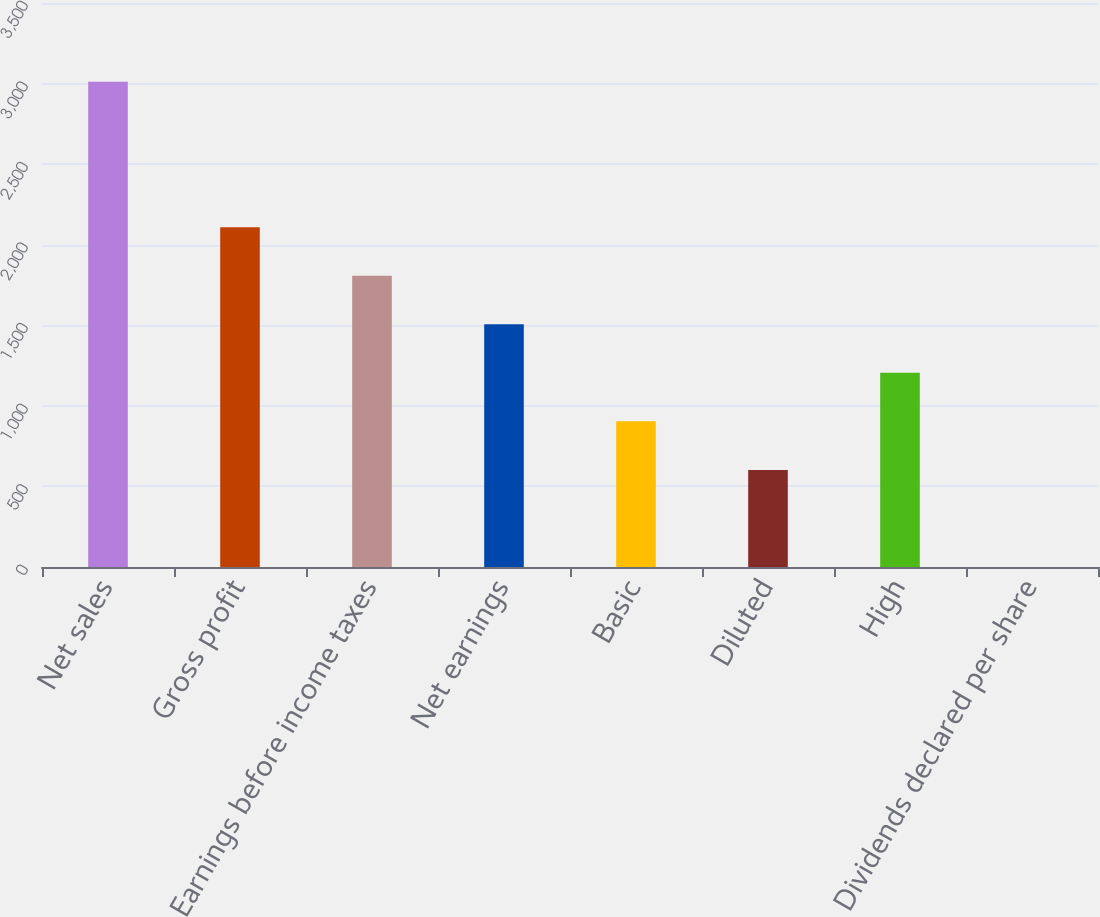<chart> <loc_0><loc_0><loc_500><loc_500><bar_chart><fcel>Net sales<fcel>Gross profit<fcel>Earnings before income taxes<fcel>Net earnings<fcel>Basic<fcel>Diluted<fcel>High<fcel>Dividends declared per share<nl><fcel>3012<fcel>2108.5<fcel>1807.34<fcel>1506.18<fcel>903.86<fcel>602.7<fcel>1205.02<fcel>0.38<nl></chart> 